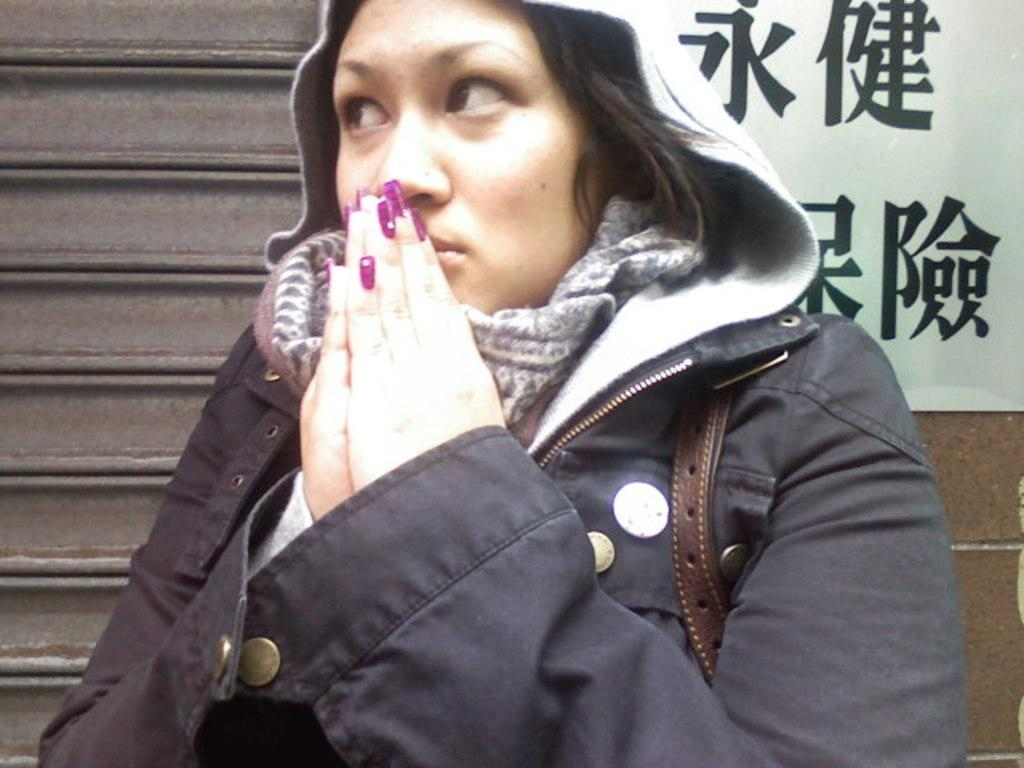Who is present in the image? There is a woman in the image. What can be seen in the background of the image? There is text written on a wall in the background of the image. What type of crow is sitting on the goat near the gate in the image? There is no crow, goat, or gate present in the image. 